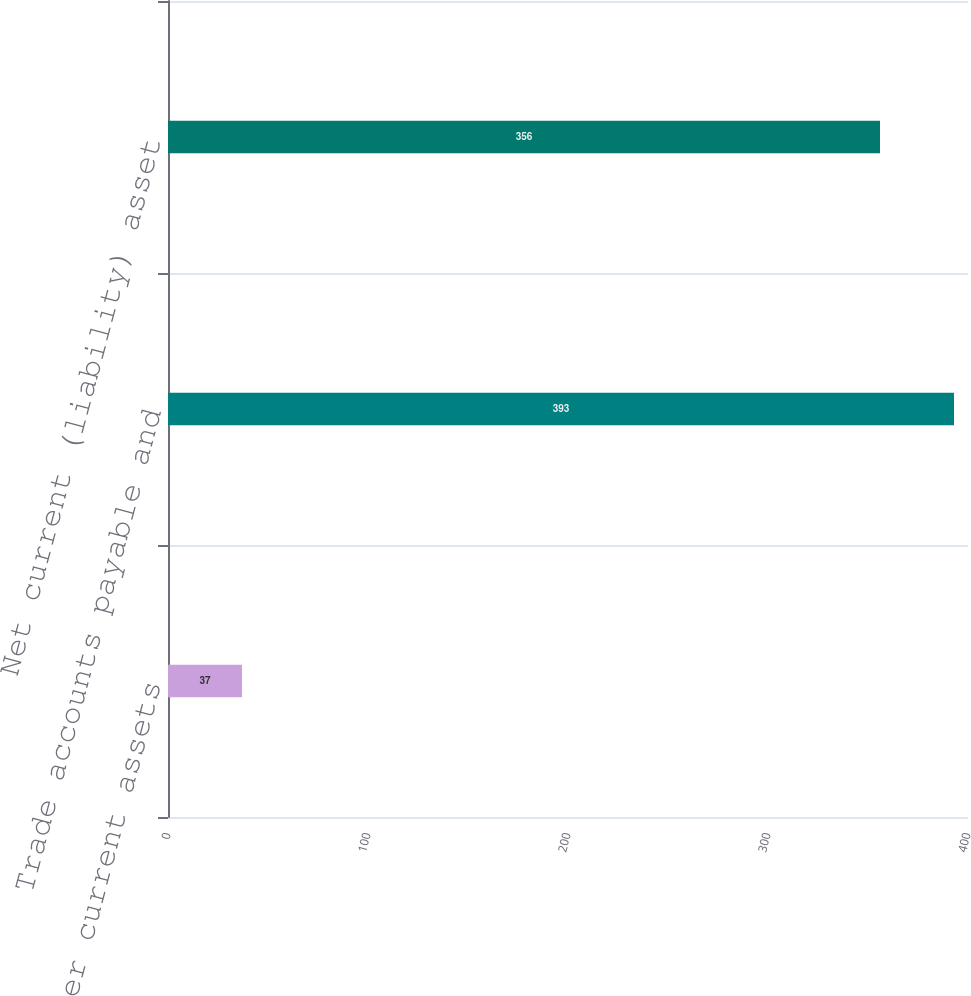Convert chart to OTSL. <chart><loc_0><loc_0><loc_500><loc_500><bar_chart><fcel>Other current assets<fcel>Trade accounts payable and<fcel>Net current (liability) asset<nl><fcel>37<fcel>393<fcel>356<nl></chart> 